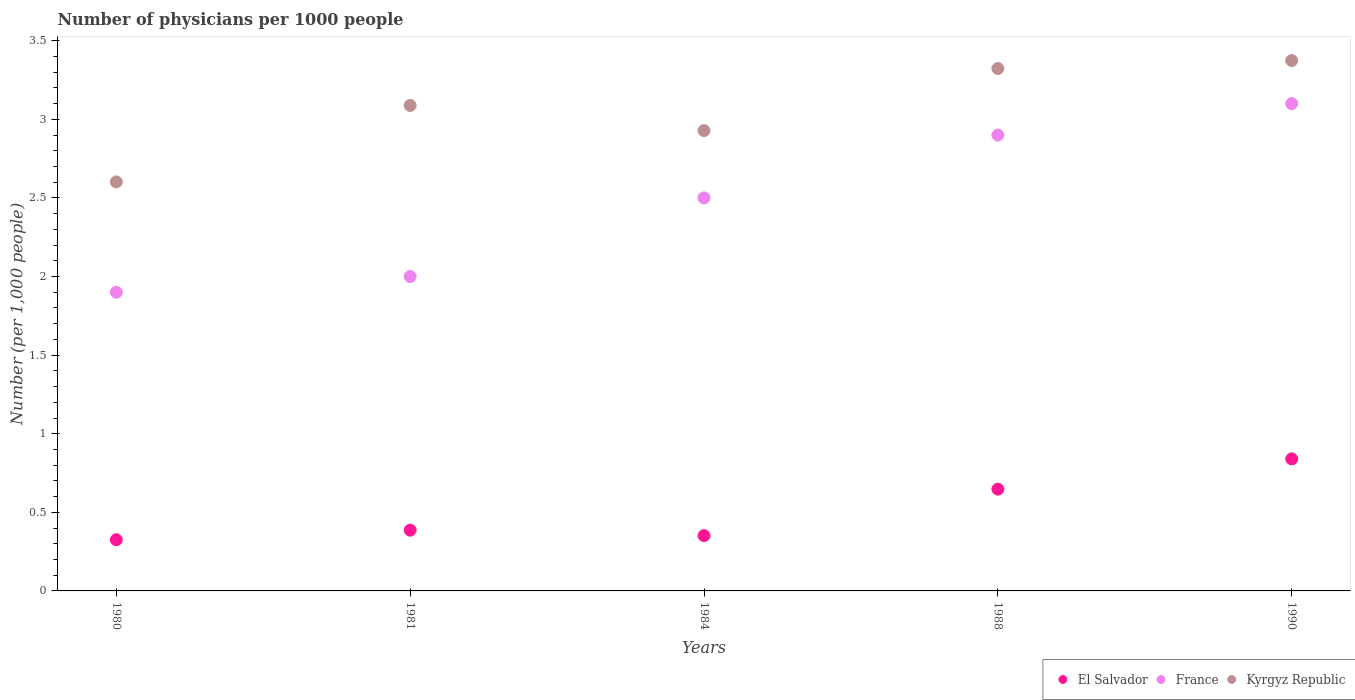What is the number of physicians in France in 1984?
Offer a terse response. 2.5. Across all years, what is the maximum number of physicians in El Salvador?
Keep it short and to the point. 0.84. Across all years, what is the minimum number of physicians in Kyrgyz Republic?
Offer a very short reply. 2.6. In which year was the number of physicians in El Salvador maximum?
Offer a very short reply. 1990. In which year was the number of physicians in El Salvador minimum?
Provide a short and direct response. 1980. What is the total number of physicians in El Salvador in the graph?
Your answer should be compact. 2.55. What is the difference between the number of physicians in France in 1980 and that in 1990?
Make the answer very short. -1.2. What is the difference between the number of physicians in El Salvador in 1984 and the number of physicians in Kyrgyz Republic in 1981?
Offer a terse response. -2.74. What is the average number of physicians in Kyrgyz Republic per year?
Provide a short and direct response. 3.06. In the year 1988, what is the difference between the number of physicians in El Salvador and number of physicians in France?
Ensure brevity in your answer.  -2.25. In how many years, is the number of physicians in France greater than 3.3?
Provide a short and direct response. 0. What is the ratio of the number of physicians in Kyrgyz Republic in 1981 to that in 1990?
Your answer should be compact. 0.92. What is the difference between the highest and the second highest number of physicians in Kyrgyz Republic?
Provide a succinct answer. 0.05. What is the difference between the highest and the lowest number of physicians in Kyrgyz Republic?
Offer a very short reply. 0.77. In how many years, is the number of physicians in Kyrgyz Republic greater than the average number of physicians in Kyrgyz Republic taken over all years?
Provide a short and direct response. 3. Is the number of physicians in France strictly greater than the number of physicians in Kyrgyz Republic over the years?
Offer a very short reply. No. How many dotlines are there?
Ensure brevity in your answer.  3. Does the graph contain grids?
Your response must be concise. No. How are the legend labels stacked?
Provide a short and direct response. Horizontal. What is the title of the graph?
Offer a terse response. Number of physicians per 1000 people. What is the label or title of the Y-axis?
Provide a succinct answer. Number (per 1,0 people). What is the Number (per 1,000 people) of El Salvador in 1980?
Your answer should be compact. 0.33. What is the Number (per 1,000 people) of Kyrgyz Republic in 1980?
Offer a terse response. 2.6. What is the Number (per 1,000 people) in El Salvador in 1981?
Provide a short and direct response. 0.39. What is the Number (per 1,000 people) of France in 1981?
Make the answer very short. 2. What is the Number (per 1,000 people) in Kyrgyz Republic in 1981?
Provide a succinct answer. 3.09. What is the Number (per 1,000 people) in El Salvador in 1984?
Your response must be concise. 0.35. What is the Number (per 1,000 people) of France in 1984?
Provide a short and direct response. 2.5. What is the Number (per 1,000 people) of Kyrgyz Republic in 1984?
Keep it short and to the point. 2.93. What is the Number (per 1,000 people) in El Salvador in 1988?
Ensure brevity in your answer.  0.65. What is the Number (per 1,000 people) in Kyrgyz Republic in 1988?
Ensure brevity in your answer.  3.32. What is the Number (per 1,000 people) of El Salvador in 1990?
Provide a succinct answer. 0.84. What is the Number (per 1,000 people) in Kyrgyz Republic in 1990?
Ensure brevity in your answer.  3.37. Across all years, what is the maximum Number (per 1,000 people) of El Salvador?
Your answer should be compact. 0.84. Across all years, what is the maximum Number (per 1,000 people) in France?
Make the answer very short. 3.1. Across all years, what is the maximum Number (per 1,000 people) of Kyrgyz Republic?
Keep it short and to the point. 3.37. Across all years, what is the minimum Number (per 1,000 people) in El Salvador?
Provide a short and direct response. 0.33. Across all years, what is the minimum Number (per 1,000 people) of Kyrgyz Republic?
Keep it short and to the point. 2.6. What is the total Number (per 1,000 people) in El Salvador in the graph?
Make the answer very short. 2.55. What is the total Number (per 1,000 people) of Kyrgyz Republic in the graph?
Ensure brevity in your answer.  15.32. What is the difference between the Number (per 1,000 people) of El Salvador in 1980 and that in 1981?
Ensure brevity in your answer.  -0.06. What is the difference between the Number (per 1,000 people) in Kyrgyz Republic in 1980 and that in 1981?
Make the answer very short. -0.49. What is the difference between the Number (per 1,000 people) of El Salvador in 1980 and that in 1984?
Offer a terse response. -0.03. What is the difference between the Number (per 1,000 people) of Kyrgyz Republic in 1980 and that in 1984?
Your answer should be very brief. -0.33. What is the difference between the Number (per 1,000 people) of El Salvador in 1980 and that in 1988?
Give a very brief answer. -0.32. What is the difference between the Number (per 1,000 people) of Kyrgyz Republic in 1980 and that in 1988?
Ensure brevity in your answer.  -0.72. What is the difference between the Number (per 1,000 people) of El Salvador in 1980 and that in 1990?
Ensure brevity in your answer.  -0.51. What is the difference between the Number (per 1,000 people) of Kyrgyz Republic in 1980 and that in 1990?
Offer a very short reply. -0.77. What is the difference between the Number (per 1,000 people) in El Salvador in 1981 and that in 1984?
Your answer should be compact. 0.03. What is the difference between the Number (per 1,000 people) of Kyrgyz Republic in 1981 and that in 1984?
Your answer should be very brief. 0.16. What is the difference between the Number (per 1,000 people) in El Salvador in 1981 and that in 1988?
Ensure brevity in your answer.  -0.26. What is the difference between the Number (per 1,000 people) in France in 1981 and that in 1988?
Your response must be concise. -0.9. What is the difference between the Number (per 1,000 people) of Kyrgyz Republic in 1981 and that in 1988?
Your response must be concise. -0.24. What is the difference between the Number (per 1,000 people) of El Salvador in 1981 and that in 1990?
Offer a very short reply. -0.45. What is the difference between the Number (per 1,000 people) in Kyrgyz Republic in 1981 and that in 1990?
Your answer should be compact. -0.29. What is the difference between the Number (per 1,000 people) in El Salvador in 1984 and that in 1988?
Offer a terse response. -0.3. What is the difference between the Number (per 1,000 people) of Kyrgyz Republic in 1984 and that in 1988?
Ensure brevity in your answer.  -0.4. What is the difference between the Number (per 1,000 people) in El Salvador in 1984 and that in 1990?
Ensure brevity in your answer.  -0.49. What is the difference between the Number (per 1,000 people) in France in 1984 and that in 1990?
Keep it short and to the point. -0.6. What is the difference between the Number (per 1,000 people) in Kyrgyz Republic in 1984 and that in 1990?
Make the answer very short. -0.45. What is the difference between the Number (per 1,000 people) of El Salvador in 1988 and that in 1990?
Offer a terse response. -0.19. What is the difference between the Number (per 1,000 people) in Kyrgyz Republic in 1988 and that in 1990?
Your answer should be compact. -0.05. What is the difference between the Number (per 1,000 people) in El Salvador in 1980 and the Number (per 1,000 people) in France in 1981?
Keep it short and to the point. -1.67. What is the difference between the Number (per 1,000 people) of El Salvador in 1980 and the Number (per 1,000 people) of Kyrgyz Republic in 1981?
Offer a very short reply. -2.76. What is the difference between the Number (per 1,000 people) of France in 1980 and the Number (per 1,000 people) of Kyrgyz Republic in 1981?
Keep it short and to the point. -1.19. What is the difference between the Number (per 1,000 people) in El Salvador in 1980 and the Number (per 1,000 people) in France in 1984?
Provide a short and direct response. -2.17. What is the difference between the Number (per 1,000 people) of El Salvador in 1980 and the Number (per 1,000 people) of Kyrgyz Republic in 1984?
Your answer should be very brief. -2.6. What is the difference between the Number (per 1,000 people) in France in 1980 and the Number (per 1,000 people) in Kyrgyz Republic in 1984?
Provide a short and direct response. -1.03. What is the difference between the Number (per 1,000 people) in El Salvador in 1980 and the Number (per 1,000 people) in France in 1988?
Keep it short and to the point. -2.57. What is the difference between the Number (per 1,000 people) in El Salvador in 1980 and the Number (per 1,000 people) in Kyrgyz Republic in 1988?
Your response must be concise. -3. What is the difference between the Number (per 1,000 people) in France in 1980 and the Number (per 1,000 people) in Kyrgyz Republic in 1988?
Your answer should be compact. -1.42. What is the difference between the Number (per 1,000 people) in El Salvador in 1980 and the Number (per 1,000 people) in France in 1990?
Provide a short and direct response. -2.77. What is the difference between the Number (per 1,000 people) of El Salvador in 1980 and the Number (per 1,000 people) of Kyrgyz Republic in 1990?
Offer a terse response. -3.05. What is the difference between the Number (per 1,000 people) in France in 1980 and the Number (per 1,000 people) in Kyrgyz Republic in 1990?
Your answer should be compact. -1.47. What is the difference between the Number (per 1,000 people) in El Salvador in 1981 and the Number (per 1,000 people) in France in 1984?
Provide a short and direct response. -2.11. What is the difference between the Number (per 1,000 people) of El Salvador in 1981 and the Number (per 1,000 people) of Kyrgyz Republic in 1984?
Offer a very short reply. -2.54. What is the difference between the Number (per 1,000 people) in France in 1981 and the Number (per 1,000 people) in Kyrgyz Republic in 1984?
Keep it short and to the point. -0.93. What is the difference between the Number (per 1,000 people) of El Salvador in 1981 and the Number (per 1,000 people) of France in 1988?
Offer a very short reply. -2.51. What is the difference between the Number (per 1,000 people) of El Salvador in 1981 and the Number (per 1,000 people) of Kyrgyz Republic in 1988?
Offer a terse response. -2.94. What is the difference between the Number (per 1,000 people) in France in 1981 and the Number (per 1,000 people) in Kyrgyz Republic in 1988?
Your answer should be compact. -1.32. What is the difference between the Number (per 1,000 people) of El Salvador in 1981 and the Number (per 1,000 people) of France in 1990?
Provide a succinct answer. -2.71. What is the difference between the Number (per 1,000 people) of El Salvador in 1981 and the Number (per 1,000 people) of Kyrgyz Republic in 1990?
Your response must be concise. -2.99. What is the difference between the Number (per 1,000 people) of France in 1981 and the Number (per 1,000 people) of Kyrgyz Republic in 1990?
Offer a terse response. -1.37. What is the difference between the Number (per 1,000 people) in El Salvador in 1984 and the Number (per 1,000 people) in France in 1988?
Offer a terse response. -2.55. What is the difference between the Number (per 1,000 people) in El Salvador in 1984 and the Number (per 1,000 people) in Kyrgyz Republic in 1988?
Offer a terse response. -2.97. What is the difference between the Number (per 1,000 people) in France in 1984 and the Number (per 1,000 people) in Kyrgyz Republic in 1988?
Ensure brevity in your answer.  -0.82. What is the difference between the Number (per 1,000 people) of El Salvador in 1984 and the Number (per 1,000 people) of France in 1990?
Offer a terse response. -2.75. What is the difference between the Number (per 1,000 people) of El Salvador in 1984 and the Number (per 1,000 people) of Kyrgyz Republic in 1990?
Offer a terse response. -3.02. What is the difference between the Number (per 1,000 people) of France in 1984 and the Number (per 1,000 people) of Kyrgyz Republic in 1990?
Offer a very short reply. -0.87. What is the difference between the Number (per 1,000 people) of El Salvador in 1988 and the Number (per 1,000 people) of France in 1990?
Give a very brief answer. -2.45. What is the difference between the Number (per 1,000 people) in El Salvador in 1988 and the Number (per 1,000 people) in Kyrgyz Republic in 1990?
Provide a succinct answer. -2.73. What is the difference between the Number (per 1,000 people) in France in 1988 and the Number (per 1,000 people) in Kyrgyz Republic in 1990?
Ensure brevity in your answer.  -0.47. What is the average Number (per 1,000 people) in El Salvador per year?
Provide a short and direct response. 0.51. What is the average Number (per 1,000 people) of France per year?
Your answer should be compact. 2.48. What is the average Number (per 1,000 people) in Kyrgyz Republic per year?
Provide a short and direct response. 3.06. In the year 1980, what is the difference between the Number (per 1,000 people) in El Salvador and Number (per 1,000 people) in France?
Make the answer very short. -1.57. In the year 1980, what is the difference between the Number (per 1,000 people) of El Salvador and Number (per 1,000 people) of Kyrgyz Republic?
Make the answer very short. -2.28. In the year 1980, what is the difference between the Number (per 1,000 people) in France and Number (per 1,000 people) in Kyrgyz Republic?
Your answer should be very brief. -0.7. In the year 1981, what is the difference between the Number (per 1,000 people) of El Salvador and Number (per 1,000 people) of France?
Give a very brief answer. -1.61. In the year 1981, what is the difference between the Number (per 1,000 people) of El Salvador and Number (per 1,000 people) of Kyrgyz Republic?
Your answer should be compact. -2.7. In the year 1981, what is the difference between the Number (per 1,000 people) in France and Number (per 1,000 people) in Kyrgyz Republic?
Offer a very short reply. -1.09. In the year 1984, what is the difference between the Number (per 1,000 people) of El Salvador and Number (per 1,000 people) of France?
Make the answer very short. -2.15. In the year 1984, what is the difference between the Number (per 1,000 people) in El Salvador and Number (per 1,000 people) in Kyrgyz Republic?
Provide a short and direct response. -2.58. In the year 1984, what is the difference between the Number (per 1,000 people) of France and Number (per 1,000 people) of Kyrgyz Republic?
Make the answer very short. -0.43. In the year 1988, what is the difference between the Number (per 1,000 people) in El Salvador and Number (per 1,000 people) in France?
Keep it short and to the point. -2.25. In the year 1988, what is the difference between the Number (per 1,000 people) in El Salvador and Number (per 1,000 people) in Kyrgyz Republic?
Give a very brief answer. -2.68. In the year 1988, what is the difference between the Number (per 1,000 people) in France and Number (per 1,000 people) in Kyrgyz Republic?
Your response must be concise. -0.42. In the year 1990, what is the difference between the Number (per 1,000 people) in El Salvador and Number (per 1,000 people) in France?
Your response must be concise. -2.26. In the year 1990, what is the difference between the Number (per 1,000 people) in El Salvador and Number (per 1,000 people) in Kyrgyz Republic?
Your answer should be compact. -2.53. In the year 1990, what is the difference between the Number (per 1,000 people) of France and Number (per 1,000 people) of Kyrgyz Republic?
Provide a succinct answer. -0.27. What is the ratio of the Number (per 1,000 people) in El Salvador in 1980 to that in 1981?
Your answer should be very brief. 0.84. What is the ratio of the Number (per 1,000 people) of France in 1980 to that in 1981?
Offer a very short reply. 0.95. What is the ratio of the Number (per 1,000 people) of Kyrgyz Republic in 1980 to that in 1981?
Provide a succinct answer. 0.84. What is the ratio of the Number (per 1,000 people) in El Salvador in 1980 to that in 1984?
Make the answer very short. 0.93. What is the ratio of the Number (per 1,000 people) of France in 1980 to that in 1984?
Provide a short and direct response. 0.76. What is the ratio of the Number (per 1,000 people) of Kyrgyz Republic in 1980 to that in 1984?
Provide a short and direct response. 0.89. What is the ratio of the Number (per 1,000 people) of El Salvador in 1980 to that in 1988?
Your answer should be compact. 0.5. What is the ratio of the Number (per 1,000 people) in France in 1980 to that in 1988?
Ensure brevity in your answer.  0.66. What is the ratio of the Number (per 1,000 people) in Kyrgyz Republic in 1980 to that in 1988?
Offer a terse response. 0.78. What is the ratio of the Number (per 1,000 people) in El Salvador in 1980 to that in 1990?
Your answer should be compact. 0.39. What is the ratio of the Number (per 1,000 people) in France in 1980 to that in 1990?
Provide a succinct answer. 0.61. What is the ratio of the Number (per 1,000 people) in Kyrgyz Republic in 1980 to that in 1990?
Ensure brevity in your answer.  0.77. What is the ratio of the Number (per 1,000 people) of El Salvador in 1981 to that in 1984?
Keep it short and to the point. 1.1. What is the ratio of the Number (per 1,000 people) of France in 1981 to that in 1984?
Give a very brief answer. 0.8. What is the ratio of the Number (per 1,000 people) in Kyrgyz Republic in 1981 to that in 1984?
Make the answer very short. 1.05. What is the ratio of the Number (per 1,000 people) of El Salvador in 1981 to that in 1988?
Provide a short and direct response. 0.6. What is the ratio of the Number (per 1,000 people) in France in 1981 to that in 1988?
Keep it short and to the point. 0.69. What is the ratio of the Number (per 1,000 people) in Kyrgyz Republic in 1981 to that in 1988?
Make the answer very short. 0.93. What is the ratio of the Number (per 1,000 people) of El Salvador in 1981 to that in 1990?
Provide a succinct answer. 0.46. What is the ratio of the Number (per 1,000 people) in France in 1981 to that in 1990?
Make the answer very short. 0.65. What is the ratio of the Number (per 1,000 people) of Kyrgyz Republic in 1981 to that in 1990?
Give a very brief answer. 0.92. What is the ratio of the Number (per 1,000 people) of El Salvador in 1984 to that in 1988?
Make the answer very short. 0.54. What is the ratio of the Number (per 1,000 people) of France in 1984 to that in 1988?
Your answer should be compact. 0.86. What is the ratio of the Number (per 1,000 people) in Kyrgyz Republic in 1984 to that in 1988?
Keep it short and to the point. 0.88. What is the ratio of the Number (per 1,000 people) in El Salvador in 1984 to that in 1990?
Your answer should be very brief. 0.42. What is the ratio of the Number (per 1,000 people) of France in 1984 to that in 1990?
Provide a short and direct response. 0.81. What is the ratio of the Number (per 1,000 people) of Kyrgyz Republic in 1984 to that in 1990?
Give a very brief answer. 0.87. What is the ratio of the Number (per 1,000 people) of El Salvador in 1988 to that in 1990?
Ensure brevity in your answer.  0.77. What is the ratio of the Number (per 1,000 people) of France in 1988 to that in 1990?
Your answer should be very brief. 0.94. What is the difference between the highest and the second highest Number (per 1,000 people) in El Salvador?
Your answer should be compact. 0.19. What is the difference between the highest and the second highest Number (per 1,000 people) in France?
Provide a succinct answer. 0.2. What is the difference between the highest and the second highest Number (per 1,000 people) of Kyrgyz Republic?
Ensure brevity in your answer.  0.05. What is the difference between the highest and the lowest Number (per 1,000 people) of El Salvador?
Offer a terse response. 0.51. What is the difference between the highest and the lowest Number (per 1,000 people) of Kyrgyz Republic?
Make the answer very short. 0.77. 